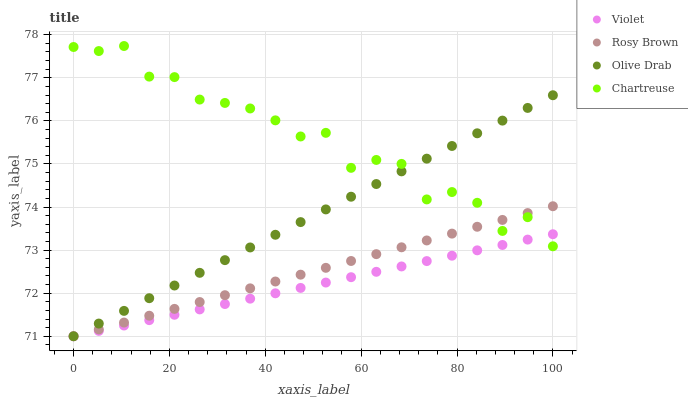Does Violet have the minimum area under the curve?
Answer yes or no. Yes. Does Chartreuse have the maximum area under the curve?
Answer yes or no. Yes. Does Rosy Brown have the minimum area under the curve?
Answer yes or no. No. Does Rosy Brown have the maximum area under the curve?
Answer yes or no. No. Is Violet the smoothest?
Answer yes or no. Yes. Is Chartreuse the roughest?
Answer yes or no. Yes. Is Rosy Brown the smoothest?
Answer yes or no. No. Is Rosy Brown the roughest?
Answer yes or no. No. Does Rosy Brown have the lowest value?
Answer yes or no. Yes. Does Chartreuse have the highest value?
Answer yes or no. Yes. Does Rosy Brown have the highest value?
Answer yes or no. No. Does Olive Drab intersect Violet?
Answer yes or no. Yes. Is Olive Drab less than Violet?
Answer yes or no. No. Is Olive Drab greater than Violet?
Answer yes or no. No. 